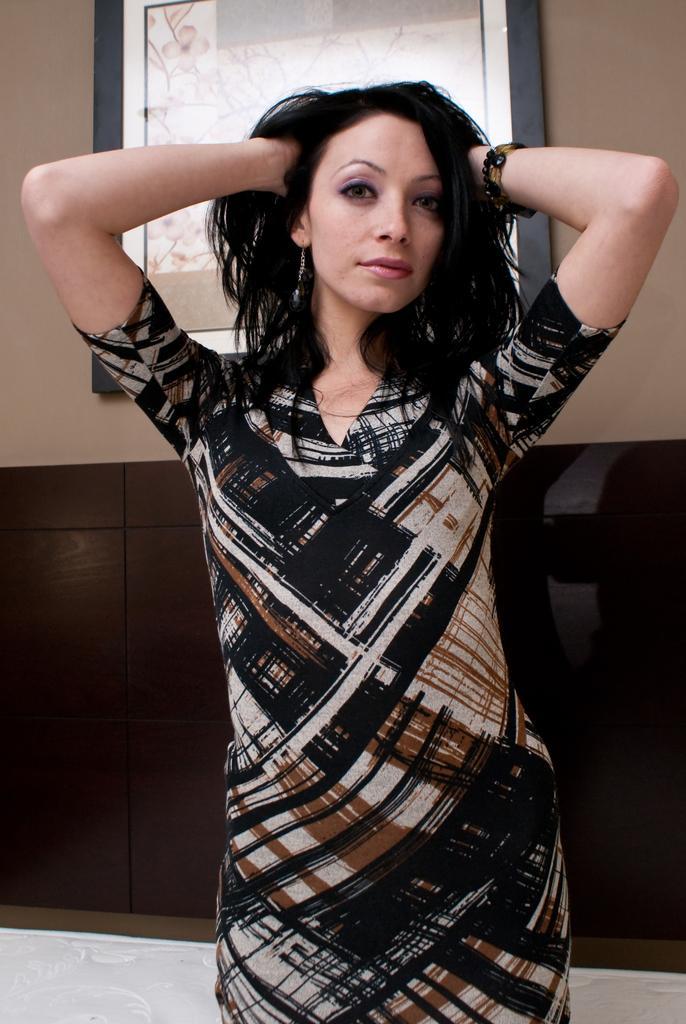Please provide a concise description of this image. In this image there is a woman standing , and in the background there is a frame attached to the wall. 